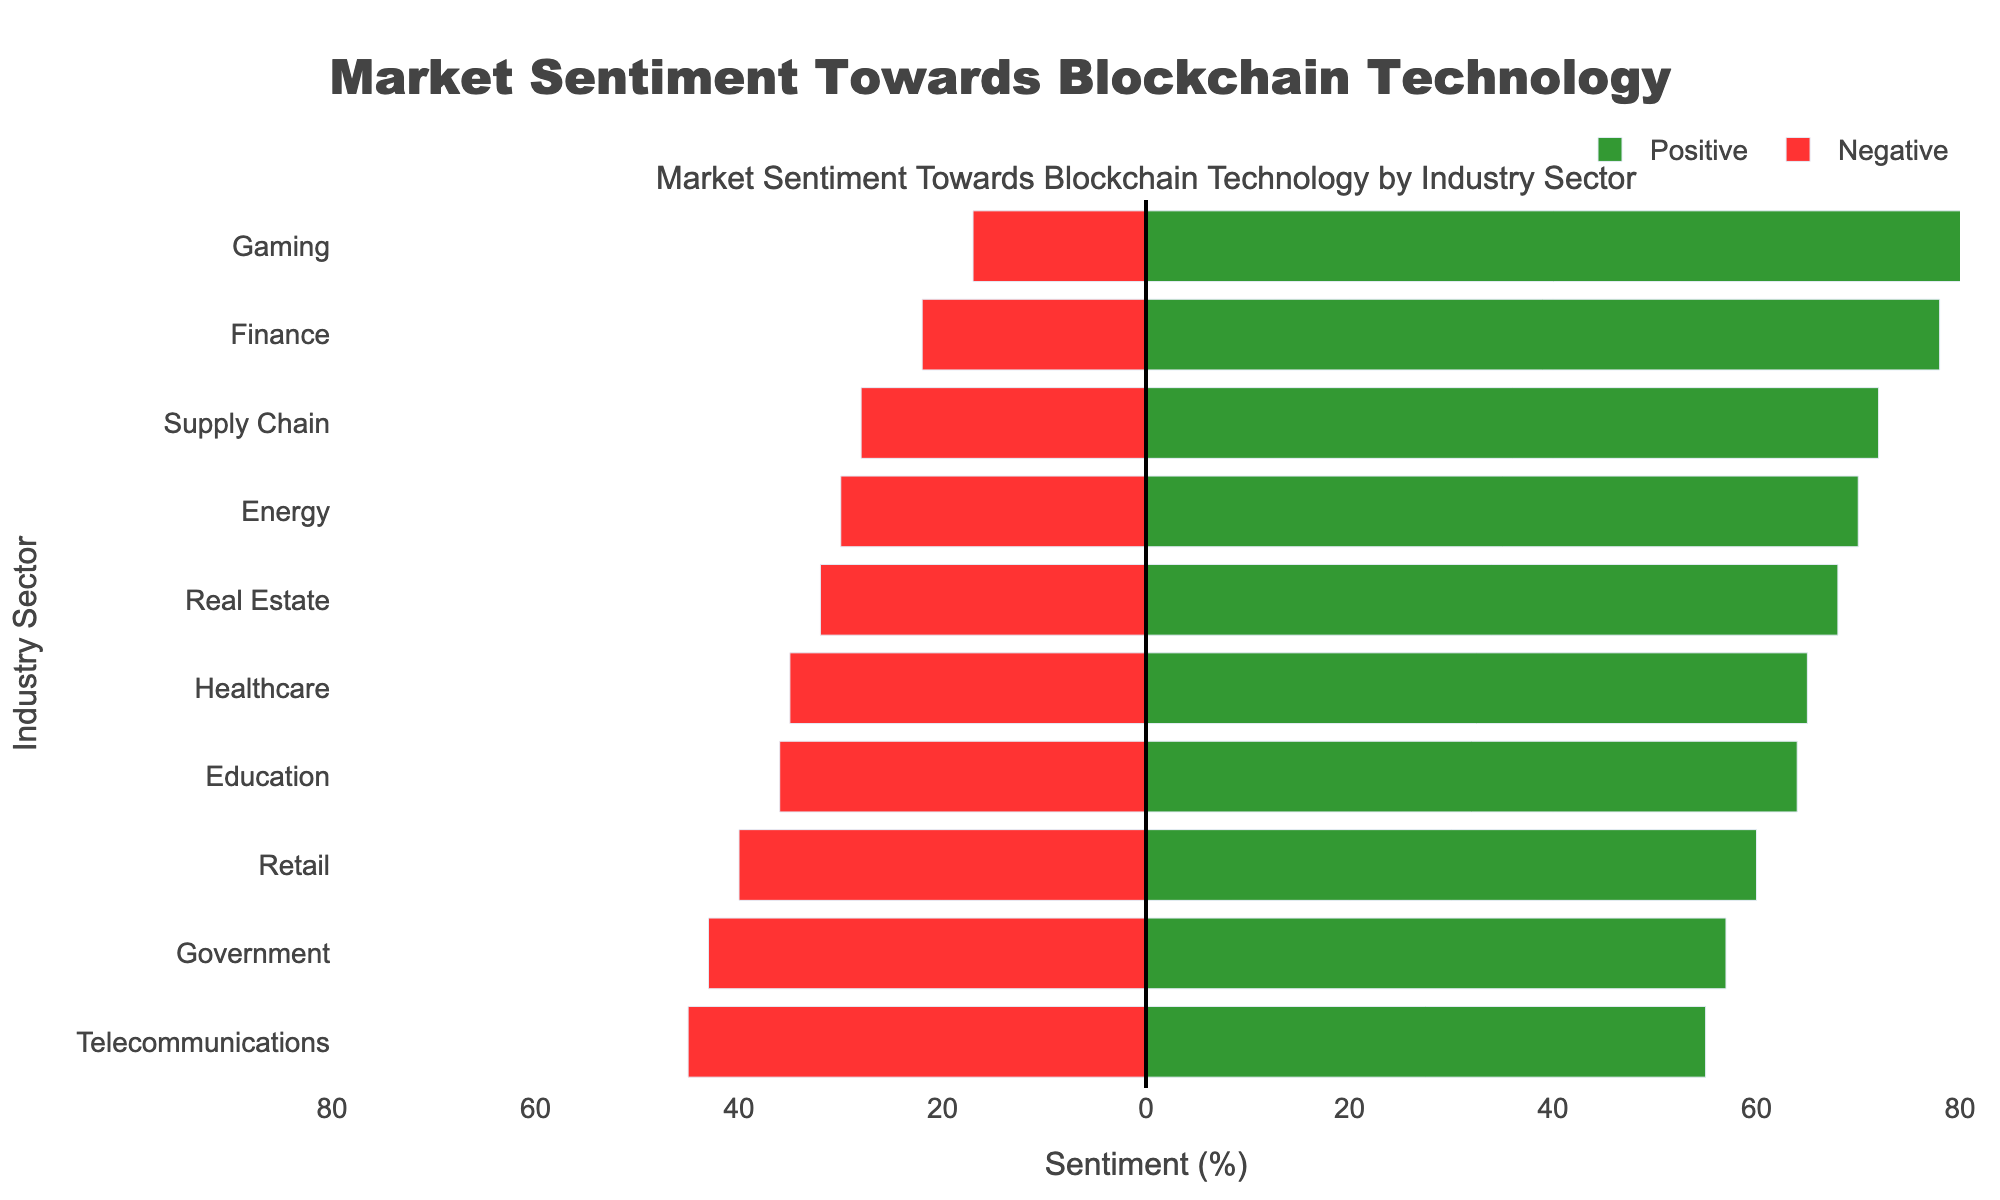Which industry sector has the highest positive sentiment? The Gaming sector shows a positive sentiment of 83%, which is higher than any other sector in the data.
Answer: Gaming How much higher is the positive sentiment in Finance compared to Retail? Positive sentiment in Finance is 78%, while in Retail it is 60%. The difference is 78% - 60% = 18%.
Answer: 18% Which industry has the largest gap between positive and negative sentiment? The Gaming sector has the largest gap, with a positive sentiment of 83% and a negative sentiment of 17%, resulting in a 66% difference.
Answer: Gaming Is there any sector where the negative sentiment is greater than the positive sentiment? No, all industry sectors have a higher positive sentiment compared to their negative sentiment.
Answer: No What is the average positive sentiment across all the industry sectors? Sum the positive sentiments: 78 + 65 + 72 + 68 + 60 + 83 + 70 + 55 + 57 + 64 = 672. Divide by the number of sectors (10): 672 / 10 = 67.2%.
Answer: 67.2% Which two sectors have the closest positive sentiment values? Real Estate (68%) and Education (64%) have the closest positive sentiment values, with a difference of just 4%.
Answer: Real Estate and Education Which industry has the lowest negative sentiment, and how much is it? Gaming has the lowest negative sentiment at 17%.
Answer: Gaming, 17% Rank the top three sectors based on positive sentiment. The top three sectors based on positive sentiment are Gaming (83%), Finance (78%), and Supply Chain (72%).
Answer: Gaming, Finance, Supply Chain 